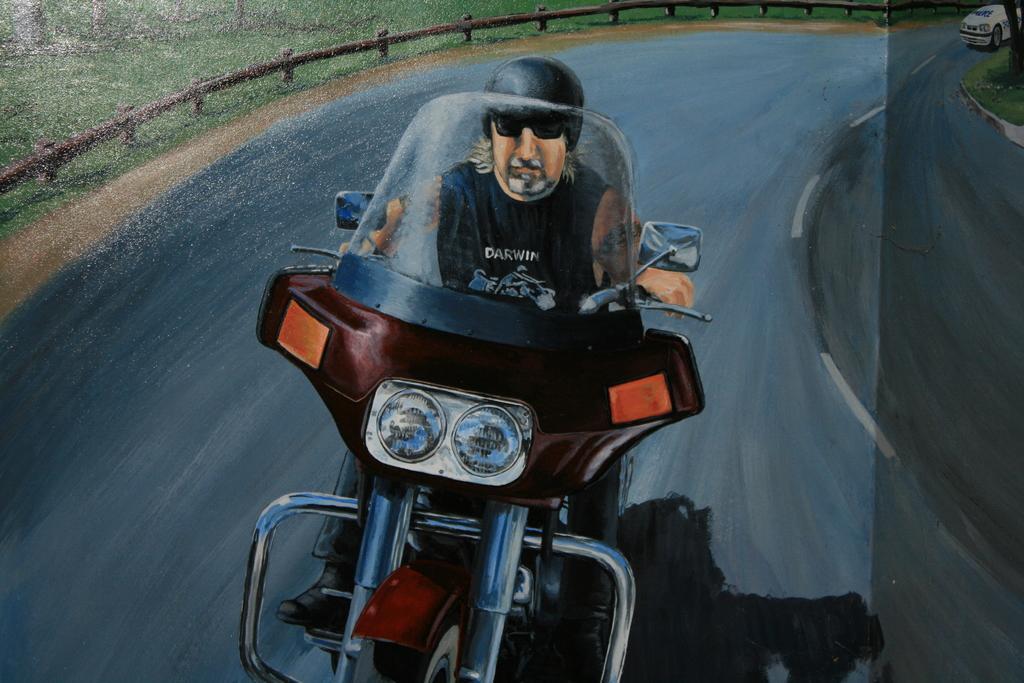Describe this image in one or two sentences. We can see the picture of a painting. In this image we can see a man is riding bike on the road. In the background we can see fence, grass on the ground and a vehicle on the road. 